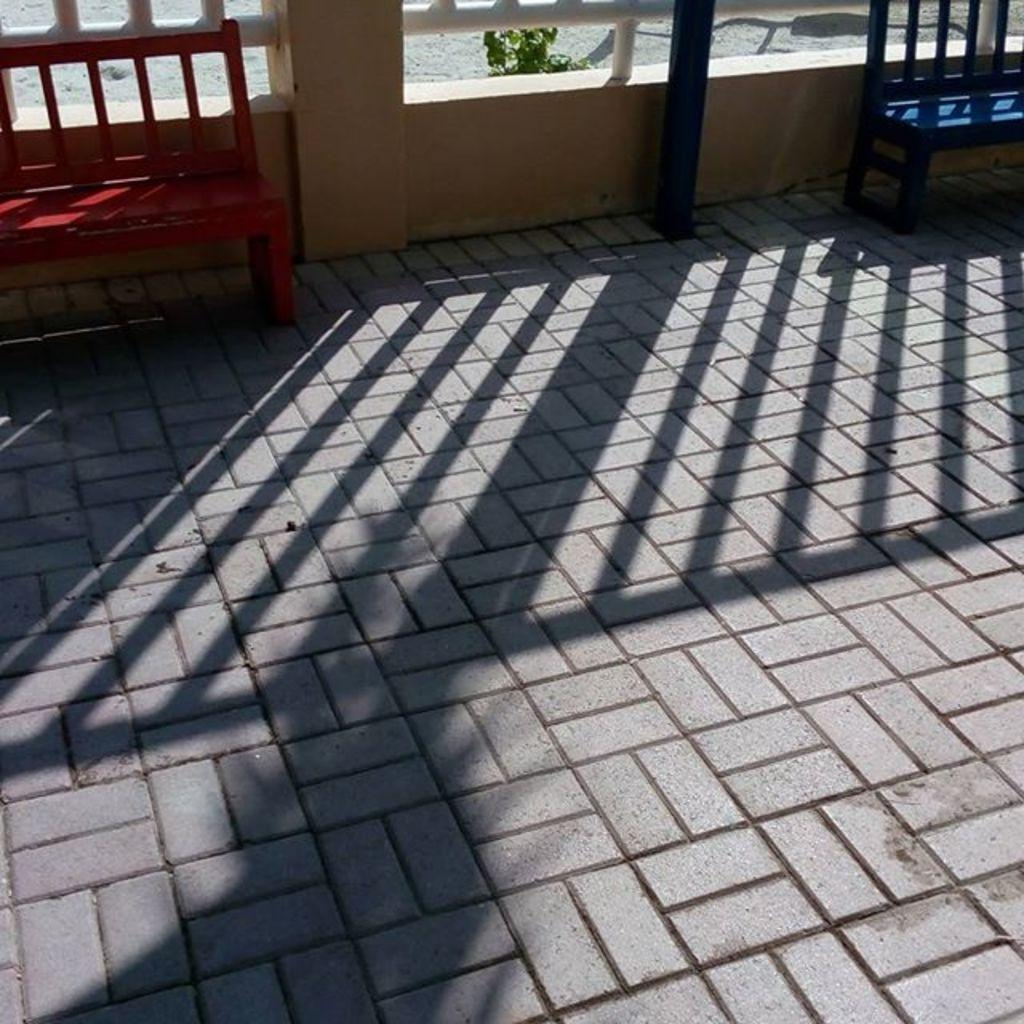What type of structure is present in the image? There is a wall in the image. How many benches can be seen in the image? There are two benches in the image. What type of vegetation is present in the image? There are plants in the image. What can be observed on the floor in the image? The shadow is visible on the floor in the image. How many bikes are parked near the wall in the image? There are no bikes present in the image. What type of expansion is visible on the wall in the image? There is no expansion visible on the wall in the image. 